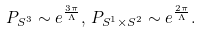Convert formula to latex. <formula><loc_0><loc_0><loc_500><loc_500>P _ { S ^ { 3 } } \sim e ^ { \frac { 3 \pi } { \Lambda } } , \, P _ { S ^ { 1 } \times S ^ { 2 } } \sim e ^ { \frac { 2 \pi } { \Lambda } } .</formula> 